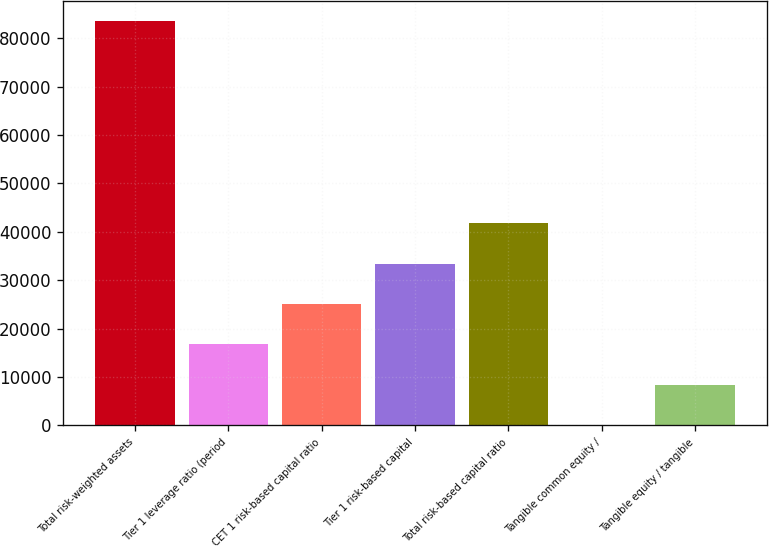Convert chart to OTSL. <chart><loc_0><loc_0><loc_500><loc_500><bar_chart><fcel>Total risk-weighted assets<fcel>Tier 1 leverage ratio (period<fcel>CET 1 risk-based capital ratio<fcel>Tier 1 risk-based capital<fcel>Total risk-based capital ratio<fcel>Tangible common equity /<fcel>Tangible equity / tangible<nl><fcel>83580<fcel>16721.8<fcel>25079.1<fcel>33436.3<fcel>41793.6<fcel>7.25<fcel>8364.52<nl></chart> 